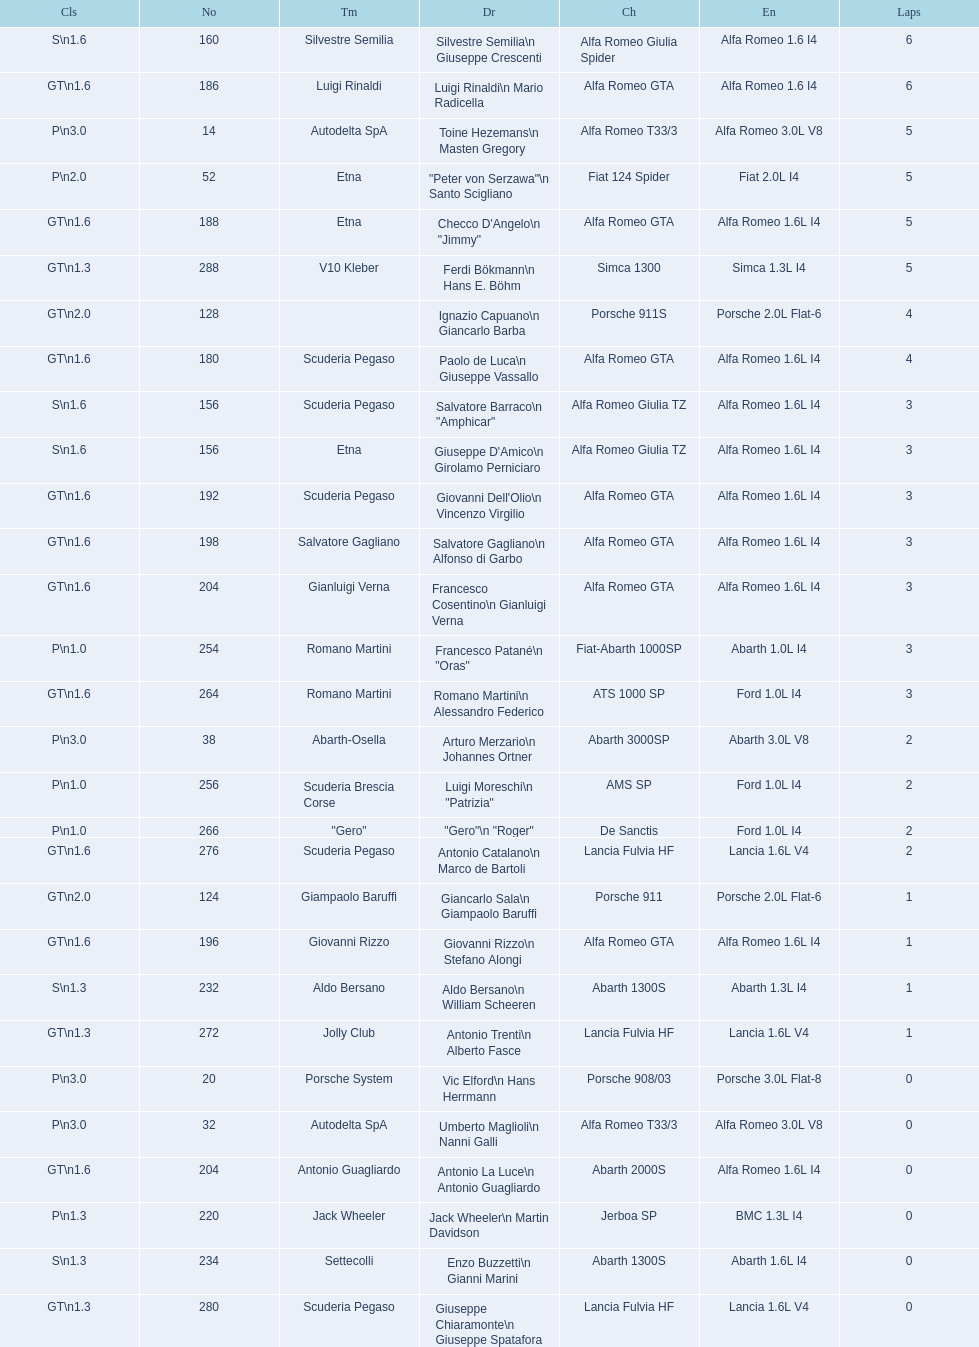How many teams did not finish the race after 2 laps? 4. 